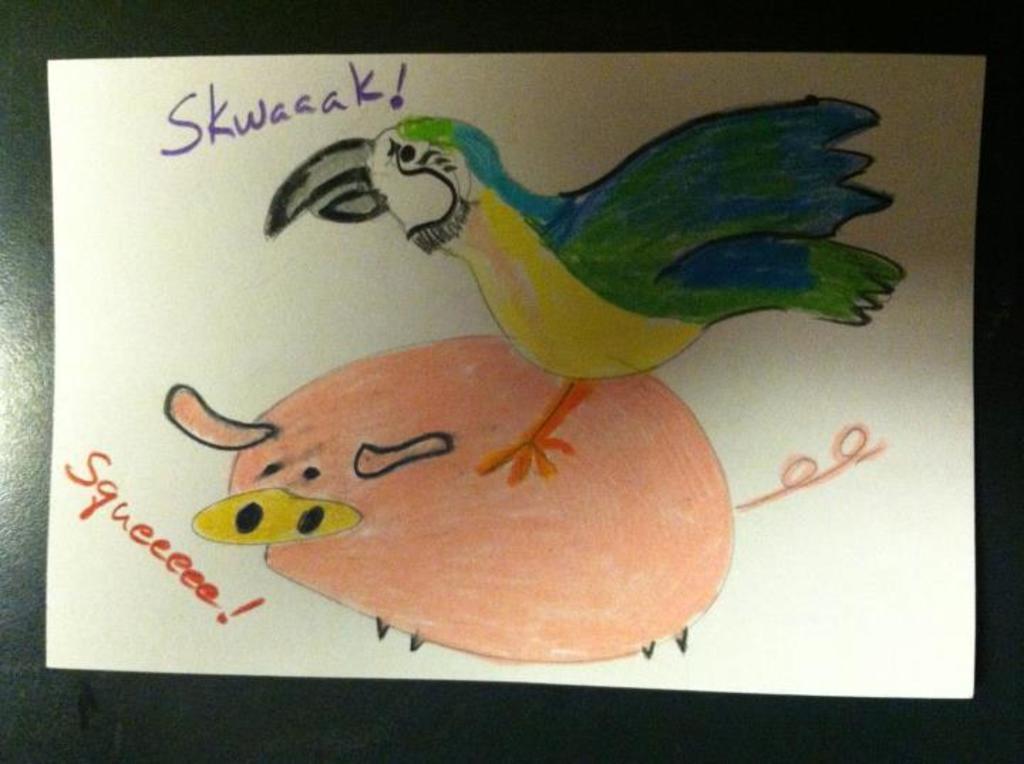Can you describe this image briefly? In this picture I can see the drawing in a paper. In the drawing I can see the bird who is standing on this this pig. This paper is kept on the table. 